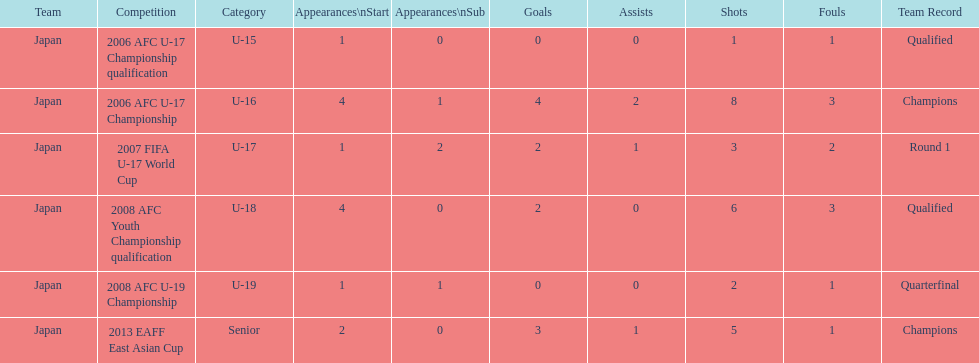Where did japan only score four goals? 2006 AFC U-17 Championship. 